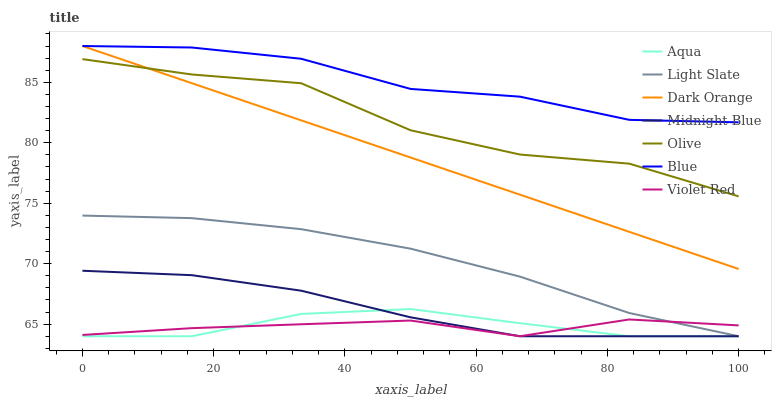Does Violet Red have the minimum area under the curve?
Answer yes or no. Yes. Does Blue have the maximum area under the curve?
Answer yes or no. Yes. Does Dark Orange have the minimum area under the curve?
Answer yes or no. No. Does Dark Orange have the maximum area under the curve?
Answer yes or no. No. Is Dark Orange the smoothest?
Answer yes or no. Yes. Is Olive the roughest?
Answer yes or no. Yes. Is Violet Red the smoothest?
Answer yes or no. No. Is Violet Red the roughest?
Answer yes or no. No. Does Dark Orange have the lowest value?
Answer yes or no. No. Does Violet Red have the highest value?
Answer yes or no. No. Is Olive less than Blue?
Answer yes or no. Yes. Is Olive greater than Midnight Blue?
Answer yes or no. Yes. Does Olive intersect Blue?
Answer yes or no. No. 